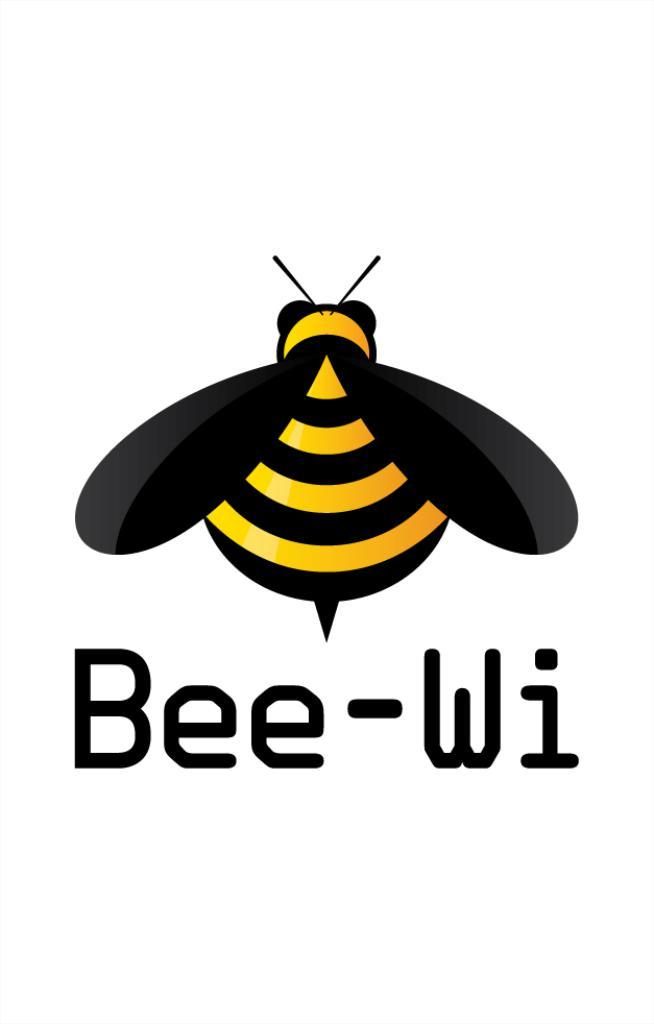What type of insect can be seen in the image? There is a bee in the image. Is there any text present in the image? Yes, there is some written text in the image. What type of boat is visible in the image? There is no boat present in the image; it features a bee and some written text. How many gloves can be seen in the image? There are no gloves present in the image. 